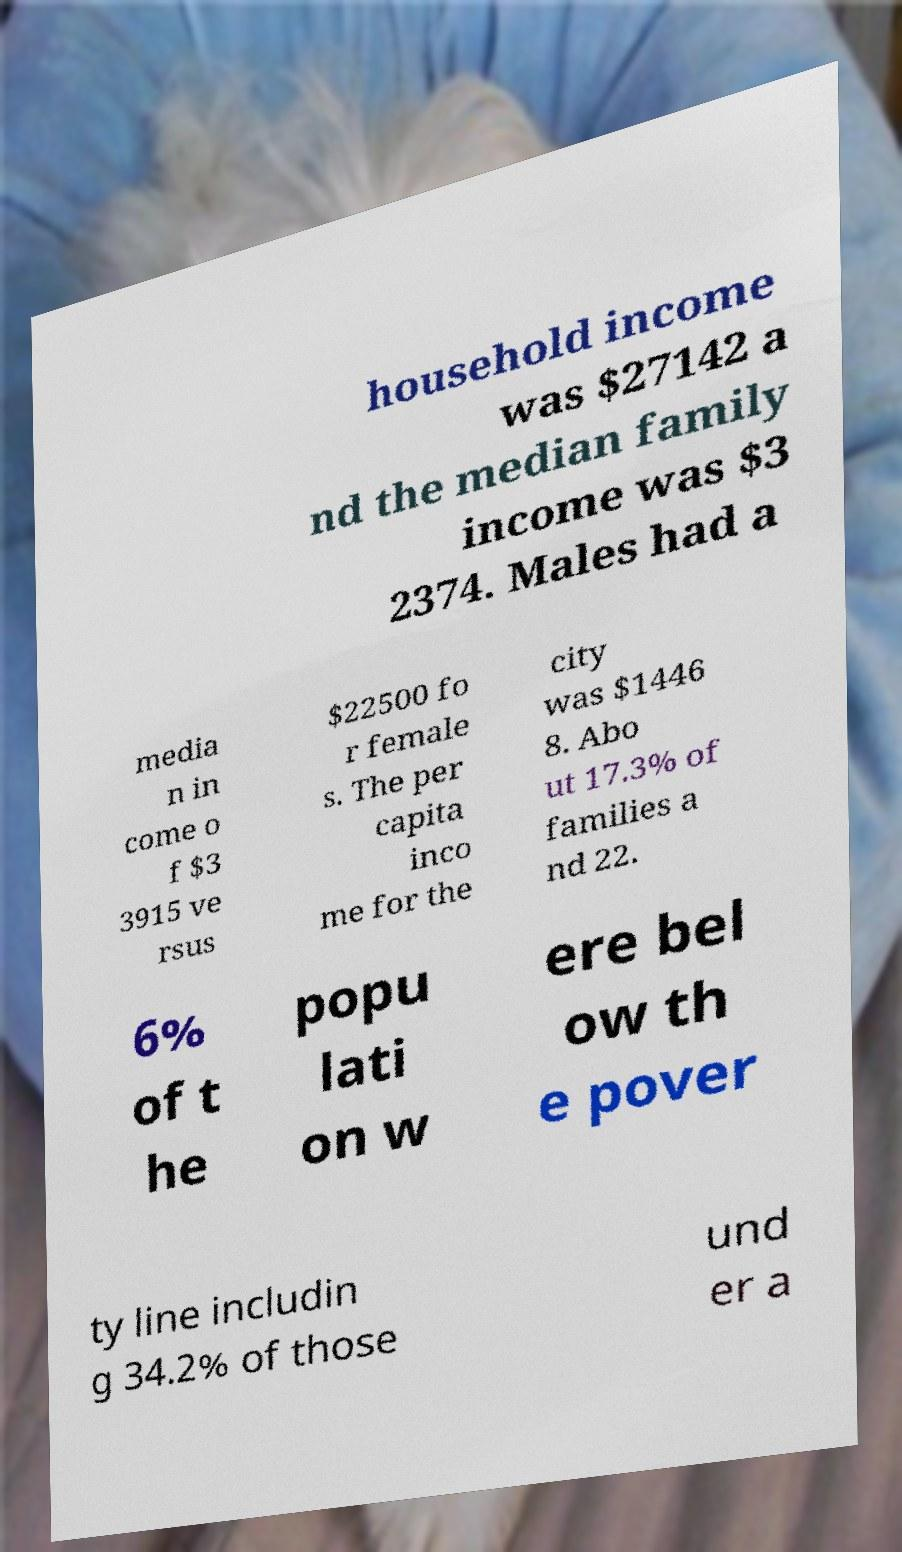Could you assist in decoding the text presented in this image and type it out clearly? household income was $27142 a nd the median family income was $3 2374. Males had a media n in come o f $3 3915 ve rsus $22500 fo r female s. The per capita inco me for the city was $1446 8. Abo ut 17.3% of families a nd 22. 6% of t he popu lati on w ere bel ow th e pover ty line includin g 34.2% of those und er a 